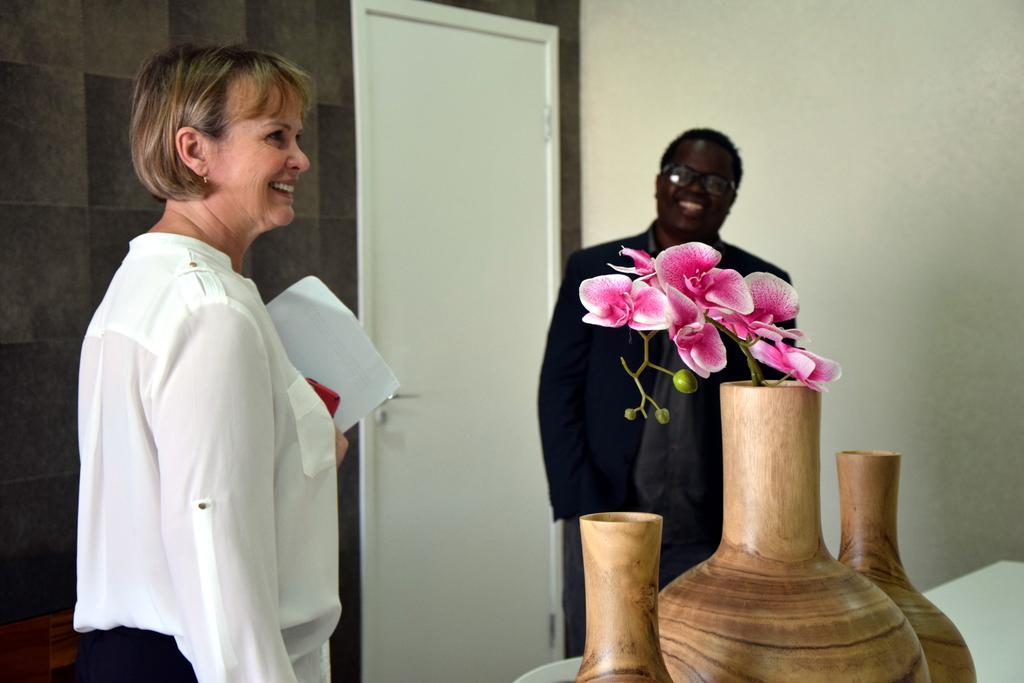Can you describe this image briefly? On the left side of the image we can see woman standing and holding paper and mobile phone. On the right side of the image we can see flower vase and man. In the background we can see wall and door. 